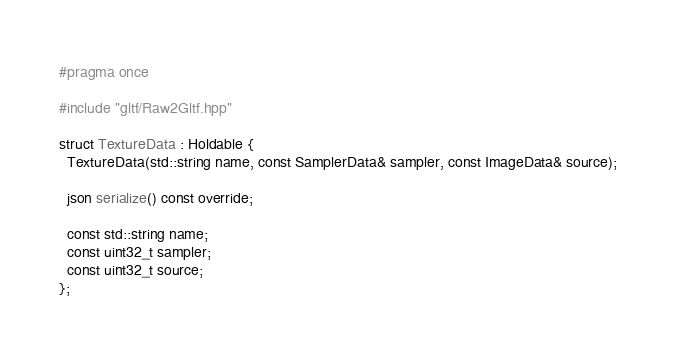Convert code to text. <code><loc_0><loc_0><loc_500><loc_500><_C++_>#pragma once

#include "gltf/Raw2Gltf.hpp"

struct TextureData : Holdable {
  TextureData(std::string name, const SamplerData& sampler, const ImageData& source);

  json serialize() const override;

  const std::string name;
  const uint32_t sampler;
  const uint32_t source;
};
</code> 